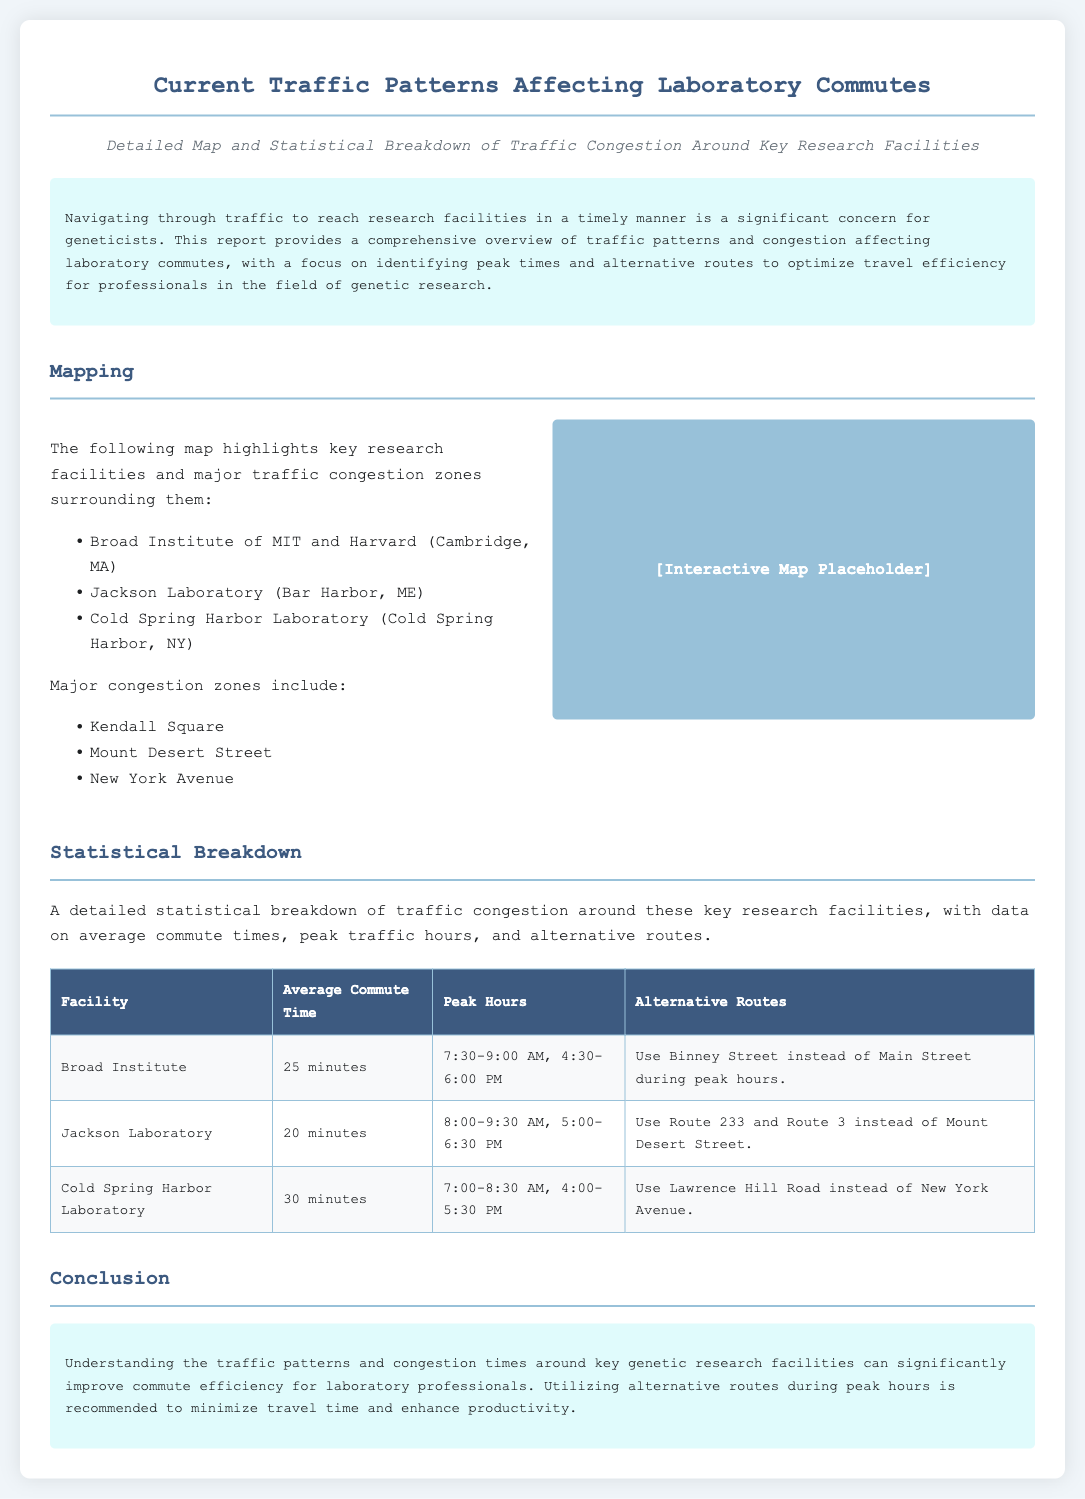What is the average commute time to the Broad Institute? The average commute time is explicitly stated in the document as 25 minutes for the Broad Institute.
Answer: 25 minutes What are the peak hours for Jackson Laboratory? The document lists the peak hours for Jackson Laboratory as 8:00-9:30 AM and 5:00-6:30 PM.
Answer: 8:00-9:30 AM, 5:00-6:30 PM Which alternative route is recommended for Cold Spring Harbor Laboratory during peak hours? The document specifies using Lawrence Hill Road instead of New York Avenue as the alternative route for Cold Spring Harbor Laboratory.
Answer: Lawrence Hill Road What is the average commute time for Cold Spring Harbor Laboratory? The report provides the average commute time for Cold Spring Harbor Laboratory as 30 minutes.
Answer: 30 minutes Which major congestion zone is mentioned in the document? The document highlights Kendall Square as one of the major congestion zones affecting laboratory commutes.
Answer: Kendall Square Which facility has the shortest average commute time? The statistical breakdown in the document indicates that Jackson Laboratory has the shortest average commute time at 20 minutes.
Answer: Jackson Laboratory What is the total number of research facilities listed in the report? The document mentions three key research facilities in detail, thus the total is three.
Answer: Three What is the background color of the document? The primary background color of the document as indicated in the style is a light shade of blue (#f0f5f9).
Answer: #f0f5f9 What time frame should geneticists avoid traveling for the Broad Institute? The peak hours for Broad Institute are 7:30-9:00 AM and 4:30-6:00 PM, which geneticists should avoid.
Answer: 7:30-9:00 AM, 4:30-6:00 PM 